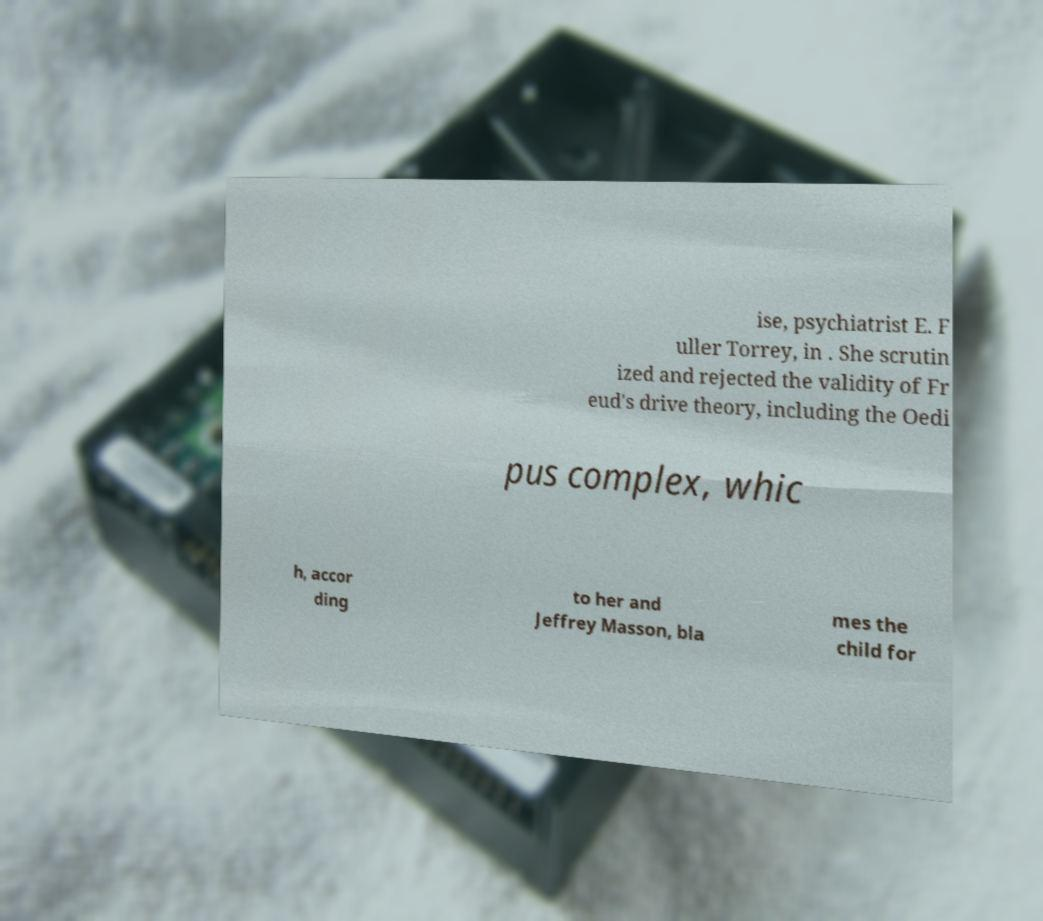For documentation purposes, I need the text within this image transcribed. Could you provide that? ise, psychiatrist E. F uller Torrey, in . She scrutin ized and rejected the validity of Fr eud's drive theory, including the Oedi pus complex, whic h, accor ding to her and Jeffrey Masson, bla mes the child for 